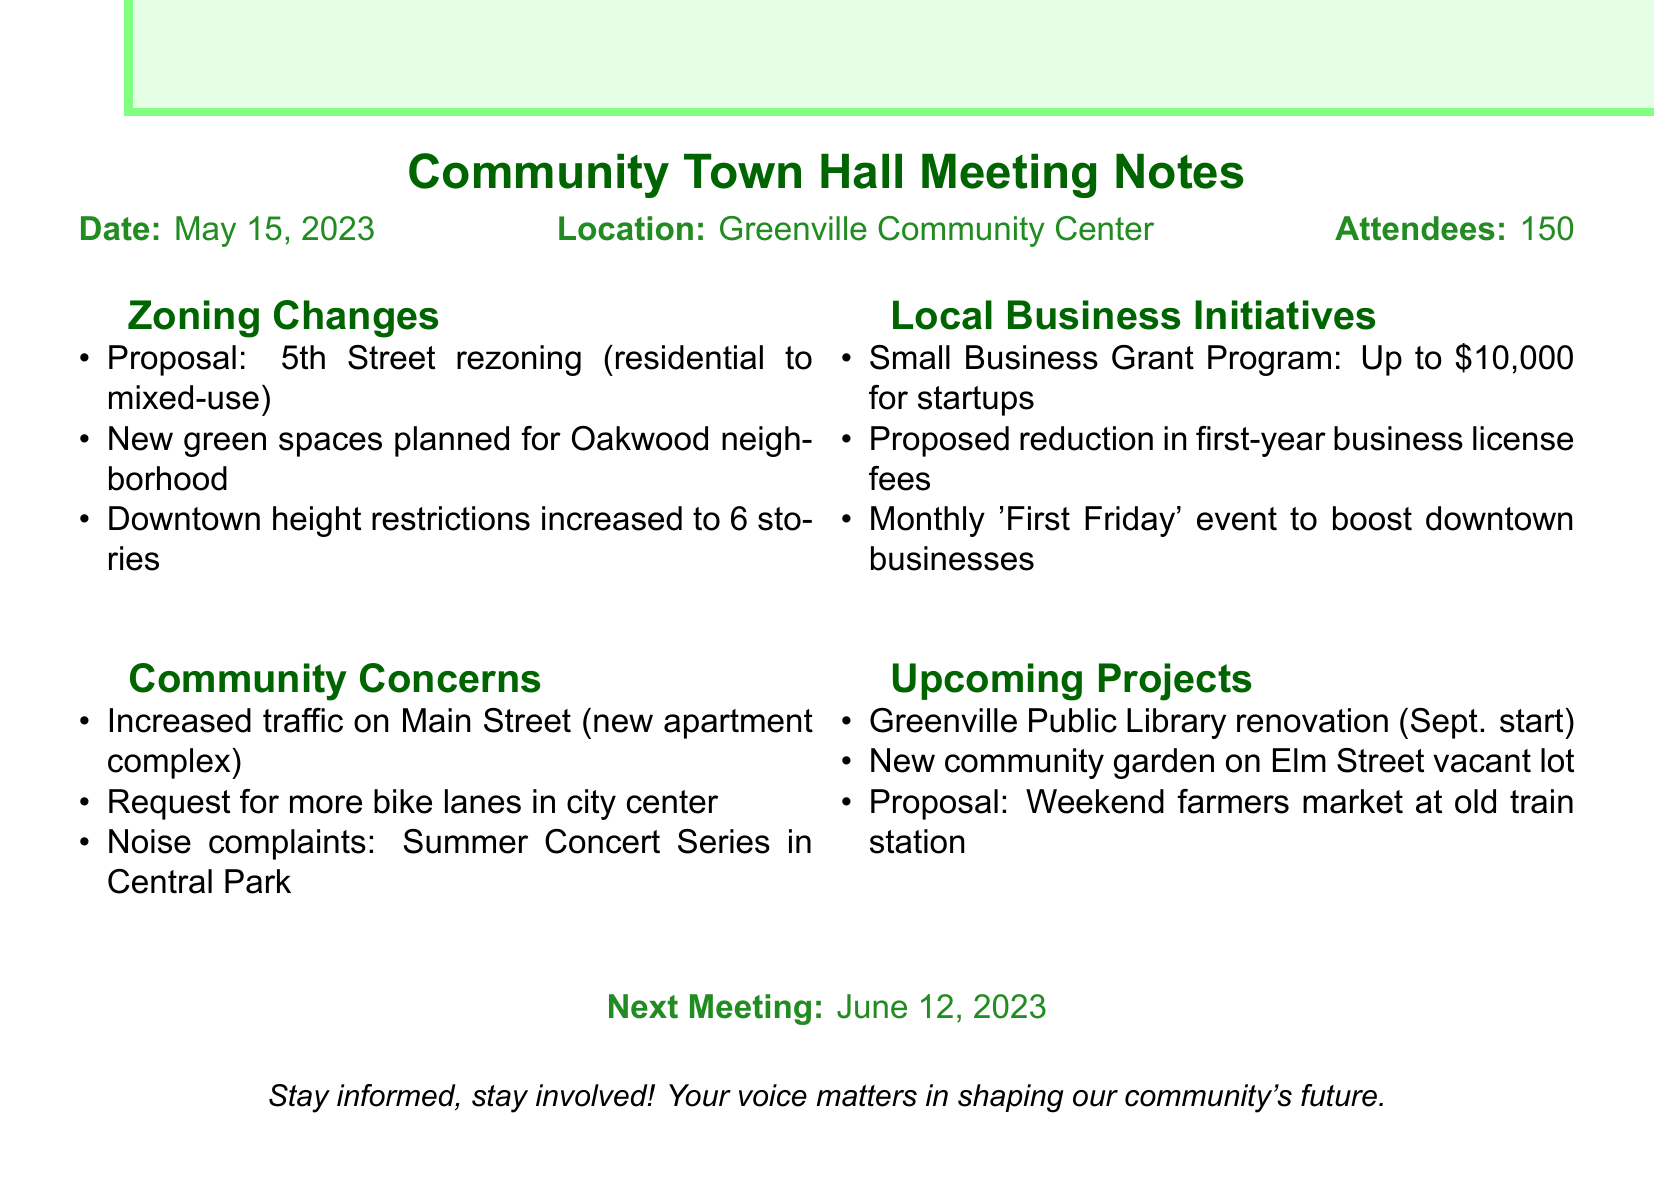What is the date of the town hall meeting? The date of the town hall meeting is explicitly stated in the document.
Answer: May 15, 2023 Where was the meeting held? The location of the meeting is mentioned in the document.
Answer: Greenville Community Center How many attendees were present? The number of attendees is clearly indicated in the notes.
Answer: 150 What is the proposed height restriction for new downtown developments? This information is found within the zoning changes section of the document.
Answer: 6 stories What is the maximum grant amount offered in the Small Business Grant Program? The amount for the grant program is specified in the local business initiatives section.
Answer: $10,000 What community concern is related to Main Street? The specific concern regarding Main Street is detailed in the community concerns section.
Answer: Increased traffic When is the Greenville Public Library renovation set to begin? The start date for the renovation is mentioned under upcoming projects.
Answer: September What is the frequency of the proposed 'First Friday' event? The document indicates how often this event is planned to occur.
Answer: Monthly What is planned for the vacant lot on Elm Street? This information is found within the upcoming projects section.
Answer: New community garden 